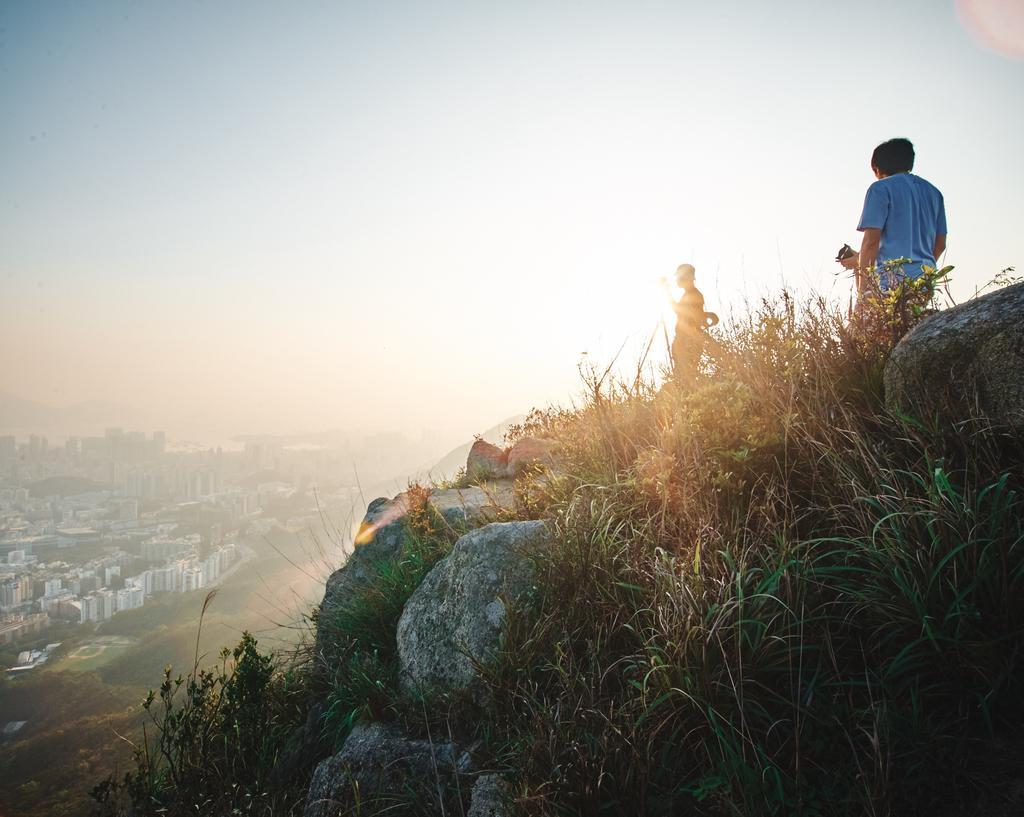Could you give a brief overview of what you see in this image? This picture is clicked outside. On the right we can see the two persons and we can see the grass, plants and the rocks. In the background we can see the sky and the buildings and some other objects. 